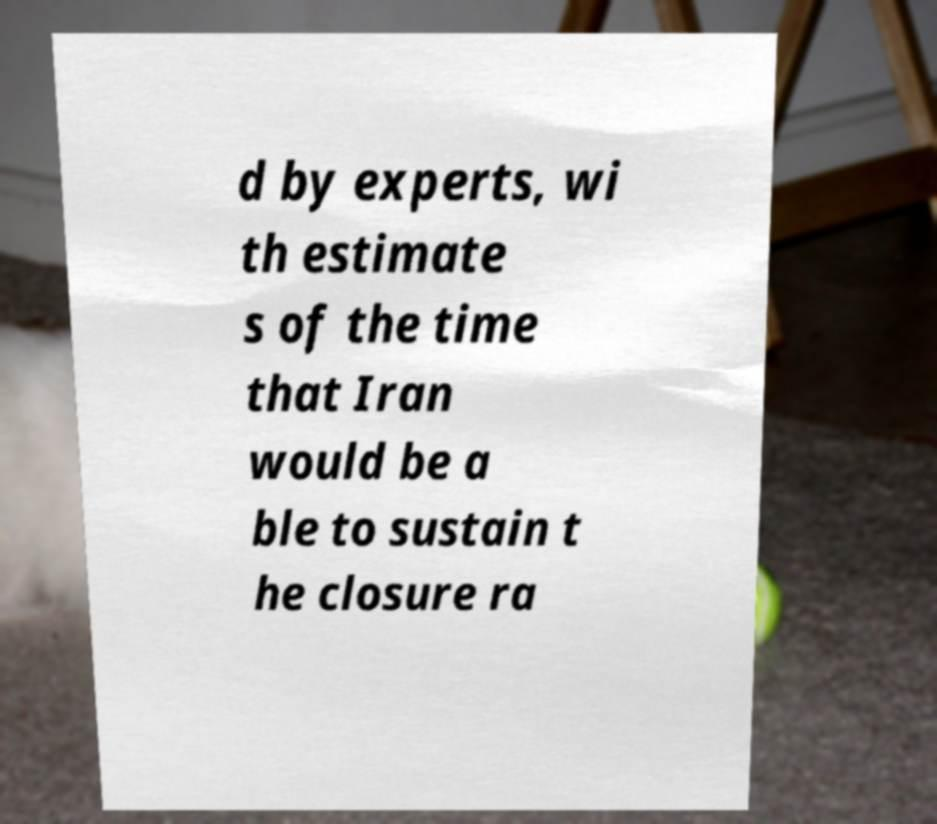Please read and relay the text visible in this image. What does it say? d by experts, wi th estimate s of the time that Iran would be a ble to sustain t he closure ra 